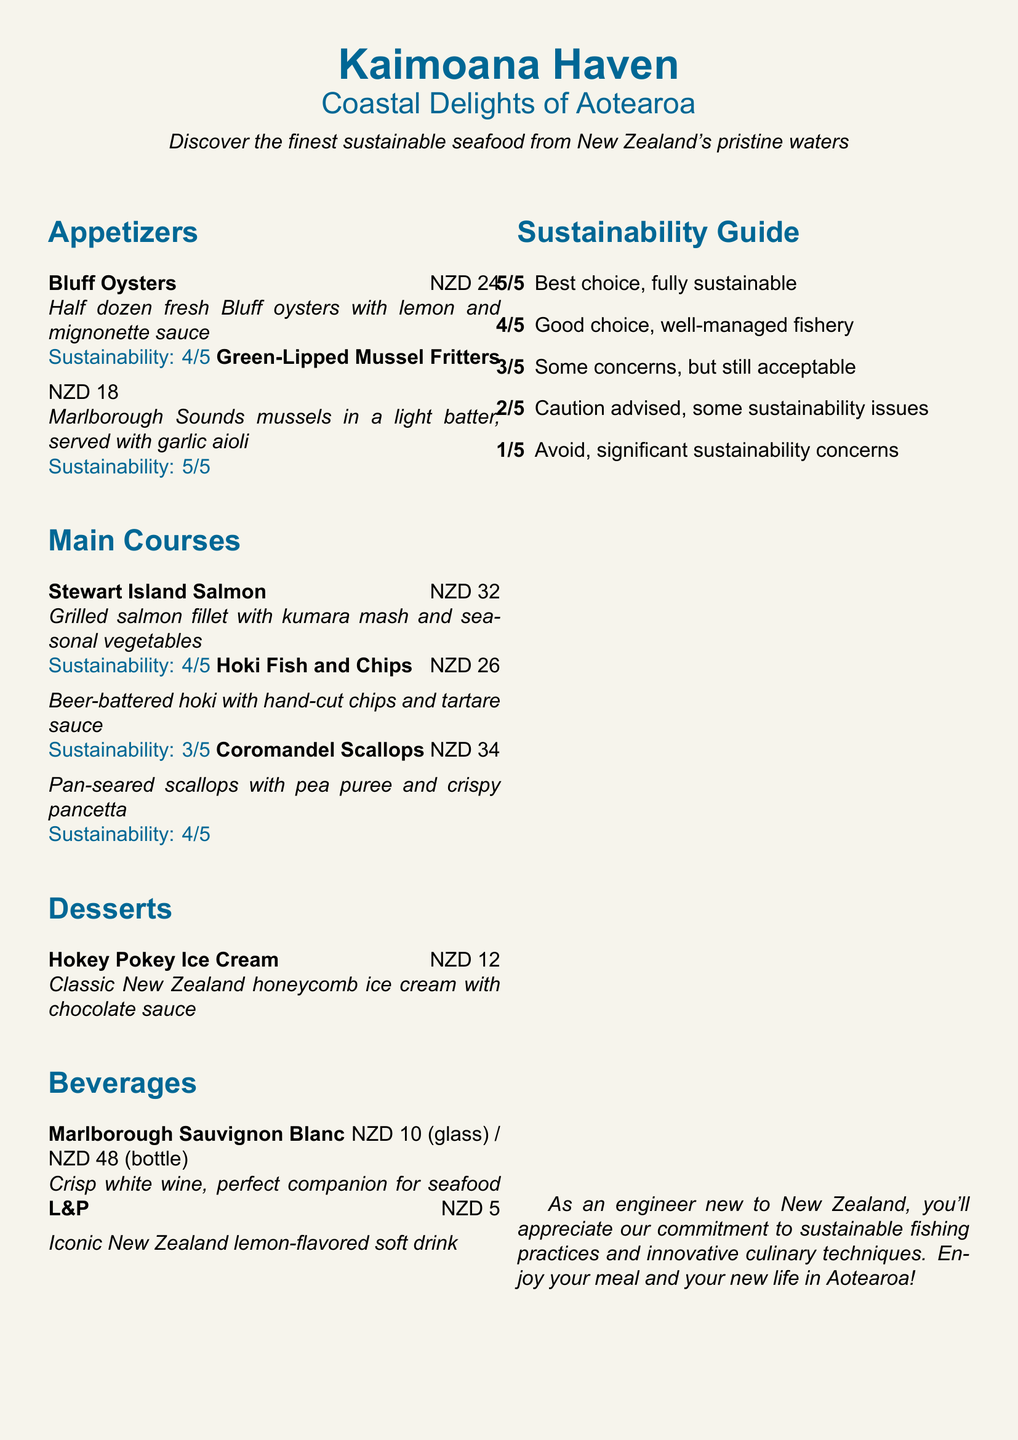What is the name of the restaurant? The restaurant name is located at the top of the menu.
Answer: Kaimoana Haven What type of cuisine does the restaurant focus on? The type of cuisine is described in the subtitle of the menu.
Answer: Coastal Delights of Aotearoa How much do Bluff Oysters cost? The price of Bluff Oysters is listed next to the menu item.
Answer: NZD 24 What is the sustainability rating of Green-Lipped Mussel Fritters? The sustainability rating is provided below the dish description.
Answer: 5/5 Which wine is suggested as a perfect companion for seafood? The beverage section mentions the wine that pairs well with seafood.
Answer: Marlborough Sauvignon Blanc What are the main ingredients in Stewart Island Salmon? The main ingredients of this dish are specified in its description.
Answer: Grilled salmon fillet, kumara mash, seasonal vegetables What is the sustainability rating of Hoki Fish and Chips? The sustainability rating can be found with the dish description.
Answer: 3/5 What dessert is available on the menu? The dessert section lists the available dessert item.
Answer: Hokey Pokey Ice Cream What should customers note about the restaurant’s fishing practices? This information is provided in the last statement of the menu.
Answer: Commitment to sustainable fishing practices 